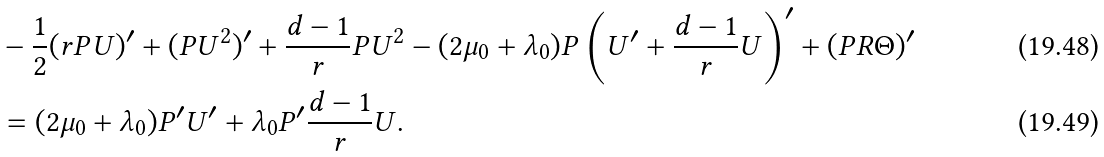<formula> <loc_0><loc_0><loc_500><loc_500>& - \frac { 1 } { 2 } ( r P U ) ^ { \prime } + ( P U ^ { 2 } ) ^ { \prime } + \frac { d - 1 } { r } P U ^ { 2 } - ( 2 \mu _ { 0 } + \lambda _ { 0 } ) P \left ( U ^ { \prime } + \frac { d - 1 } { r } U \right ) ^ { \prime } + ( P R \Theta ) ^ { \prime } \\ & = ( 2 \mu _ { 0 } + \lambda _ { 0 } ) P ^ { \prime } U ^ { \prime } + \lambda _ { 0 } P ^ { \prime } \frac { d - 1 } { r } U .</formula> 